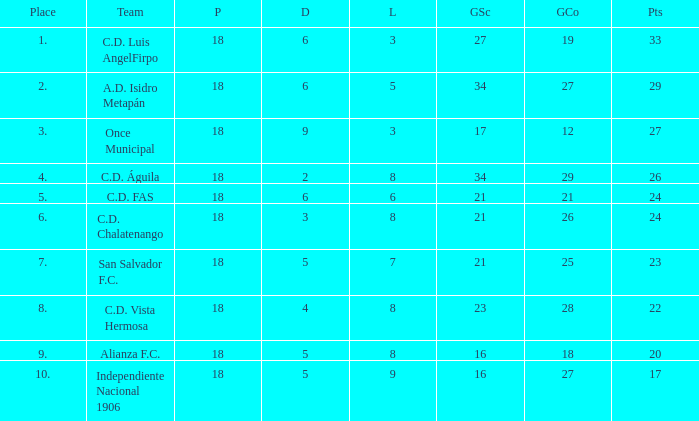What is the lowest amount of goals scored that has more than 19 goal conceded and played less than 18? None. 